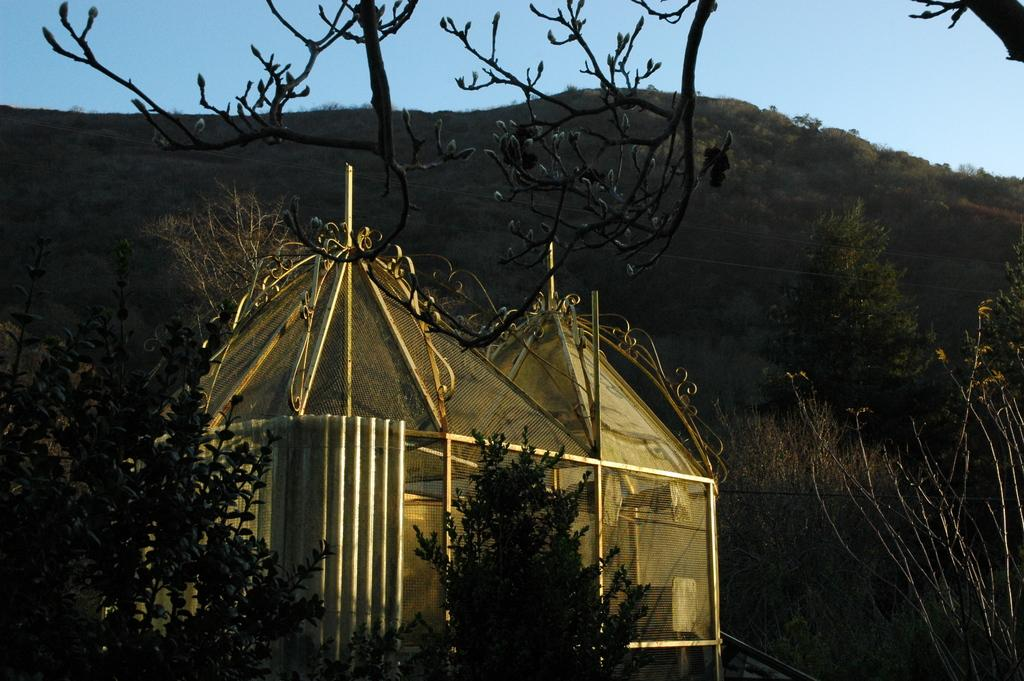What type of structure is in the image? There is a shed in the image. What is located near the shed? The shed is near grass and plants. What can be seen in the background of the image? There are trees on a mountain in the background of the image. What is visible at the top of the image? The sky is visible at the top of the image. Are there any nets visible in the image? No, there are no nets present in the image. Can you see any giants in the image? No, there are no giants present in the image. 